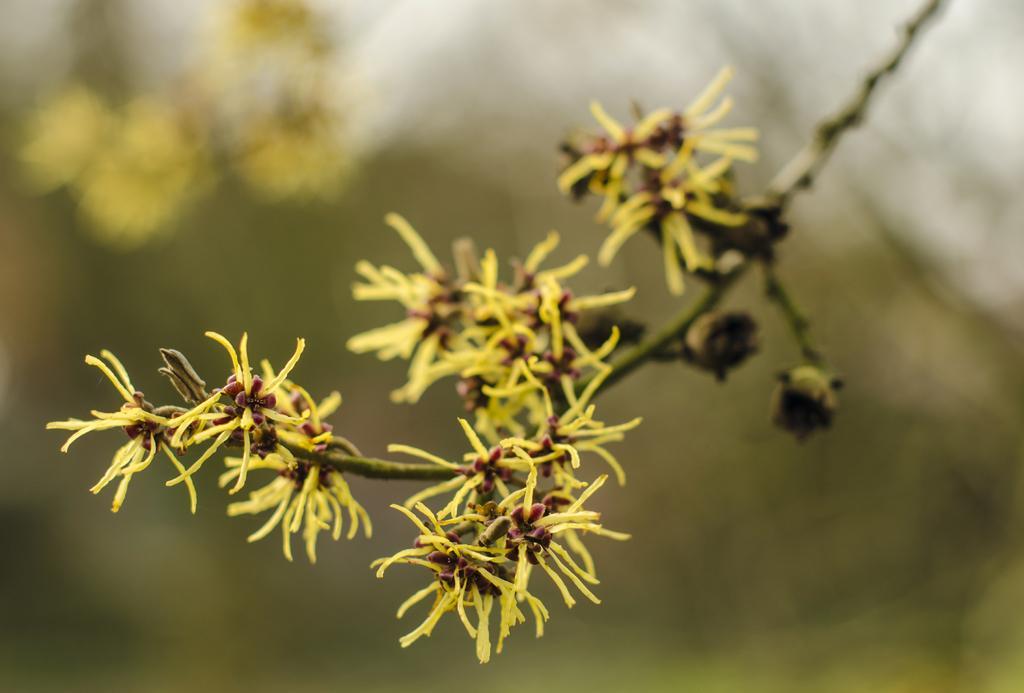In one or two sentences, can you explain what this image depicts? In this image we can see group of flowers and buds on the branch of a tree. 